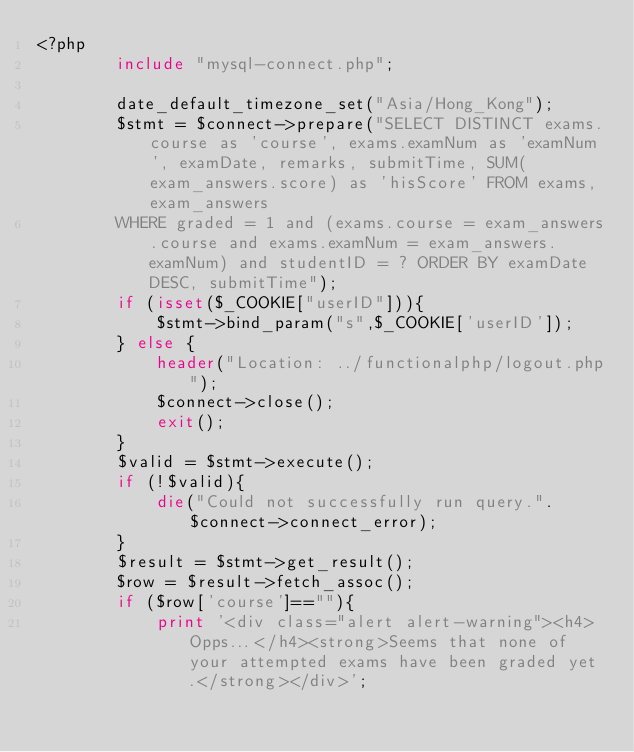Convert code to text. <code><loc_0><loc_0><loc_500><loc_500><_PHP_><?php
        include "mysql-connect.php";

        date_default_timezone_set("Asia/Hong_Kong");
        $stmt = $connect->prepare("SELECT DISTINCT exams.course as 'course', exams.examNum as 'examNum', examDate, remarks, submitTime, SUM(exam_answers.score) as 'hisScore' FROM exams, exam_answers 
        WHERE graded = 1 and (exams.course = exam_answers.course and exams.examNum = exam_answers.examNum) and studentID = ? ORDER BY examDate DESC, submitTime");
        if (isset($_COOKIE["userID"])){
            $stmt->bind_param("s",$_COOKIE['userID']);
        } else {
            header("Location: ../functionalphp/logout.php");
            $connect->close();
            exit();
        }
        $valid = $stmt->execute();
	    if (!$valid){
	    	die("Could not successfully run query.". $connect->connect_error);
        }
        $result = $stmt->get_result();
        $row = $result->fetch_assoc();
        if ($row['course']==""){
            print '<div class="alert alert-warning"><h4>Opps...</h4><strong>Seems that none of your attempted exams have been graded yet.</strong></div>';</code> 